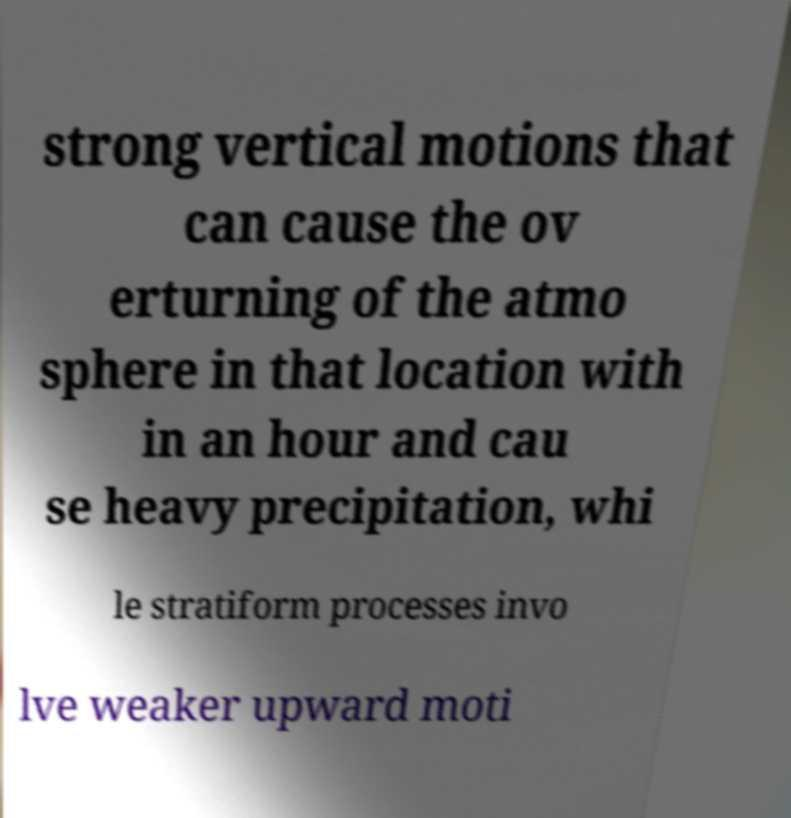Could you extract and type out the text from this image? strong vertical motions that can cause the ov erturning of the atmo sphere in that location with in an hour and cau se heavy precipitation, whi le stratiform processes invo lve weaker upward moti 